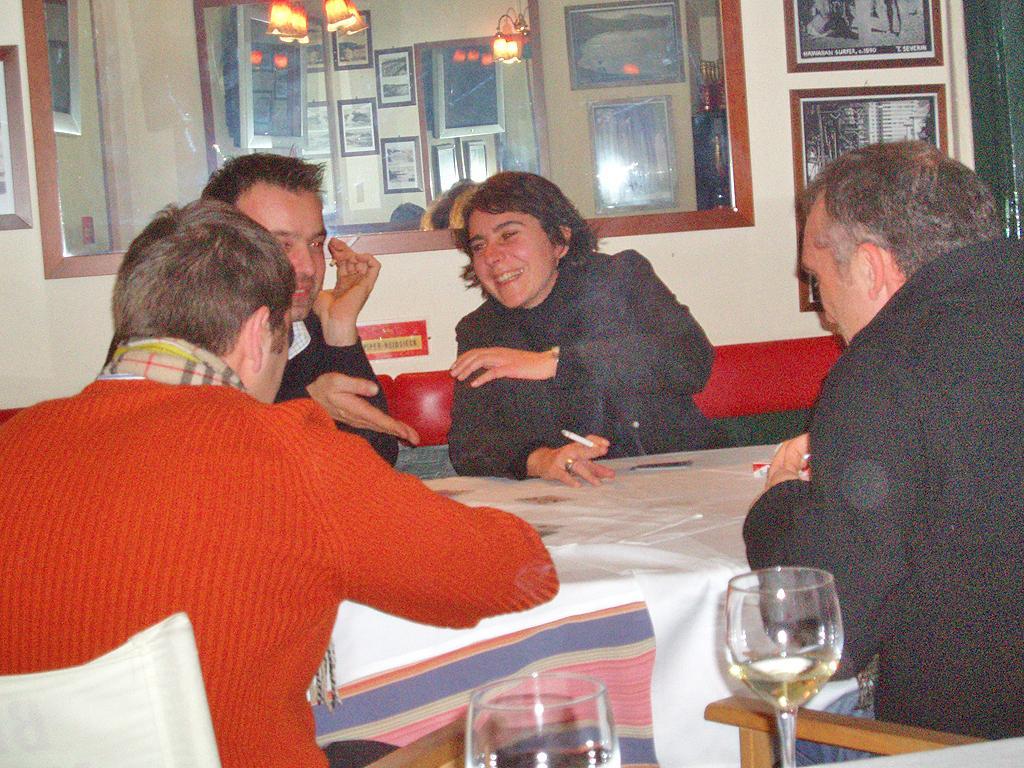Please provide a concise description of this image. In the image,there are total four people,three men and one woman, the woman is smoking,backside on the chair there are two glasses visible,there is a white color cloth placed on the table,in the background to the wall there are many photo posters stick to the wall. 